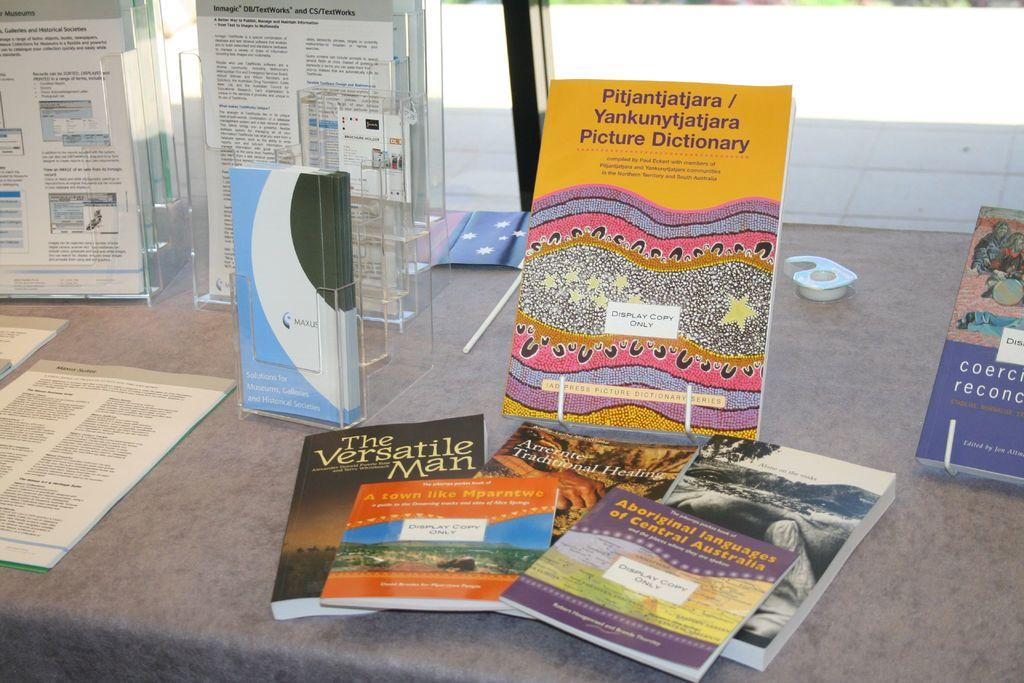<image>
Present a compact description of the photo's key features. a couple of books by each other with one that is titled 'pitjantjatjara' 